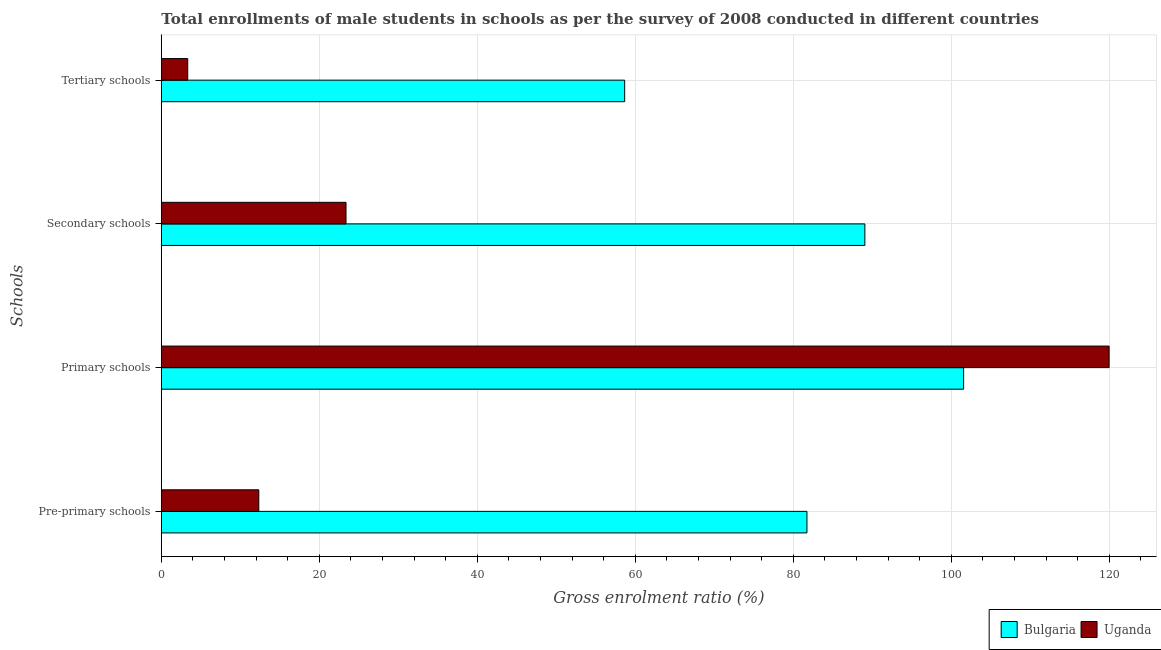How many bars are there on the 4th tick from the top?
Make the answer very short. 2. What is the label of the 2nd group of bars from the top?
Make the answer very short. Secondary schools. What is the gross enrolment ratio(male) in primary schools in Bulgaria?
Give a very brief answer. 101.55. Across all countries, what is the maximum gross enrolment ratio(male) in tertiary schools?
Give a very brief answer. 58.65. Across all countries, what is the minimum gross enrolment ratio(male) in pre-primary schools?
Give a very brief answer. 12.34. In which country was the gross enrolment ratio(male) in secondary schools minimum?
Offer a terse response. Uganda. What is the total gross enrolment ratio(male) in tertiary schools in the graph?
Ensure brevity in your answer.  61.99. What is the difference between the gross enrolment ratio(male) in pre-primary schools in Bulgaria and that in Uganda?
Your answer should be compact. 69.38. What is the difference between the gross enrolment ratio(male) in tertiary schools in Uganda and the gross enrolment ratio(male) in primary schools in Bulgaria?
Offer a terse response. -98.21. What is the average gross enrolment ratio(male) in primary schools per country?
Offer a very short reply. 110.76. What is the difference between the gross enrolment ratio(male) in secondary schools and gross enrolment ratio(male) in primary schools in Uganda?
Make the answer very short. -96.59. In how many countries, is the gross enrolment ratio(male) in pre-primary schools greater than 36 %?
Keep it short and to the point. 1. What is the ratio of the gross enrolment ratio(male) in secondary schools in Bulgaria to that in Uganda?
Give a very brief answer. 3.81. Is the gross enrolment ratio(male) in primary schools in Bulgaria less than that in Uganda?
Offer a very short reply. Yes. Is the difference between the gross enrolment ratio(male) in primary schools in Bulgaria and Uganda greater than the difference between the gross enrolment ratio(male) in secondary schools in Bulgaria and Uganda?
Offer a very short reply. No. What is the difference between the highest and the second highest gross enrolment ratio(male) in tertiary schools?
Make the answer very short. 55.31. What is the difference between the highest and the lowest gross enrolment ratio(male) in pre-primary schools?
Give a very brief answer. 69.38. Is it the case that in every country, the sum of the gross enrolment ratio(male) in tertiary schools and gross enrolment ratio(male) in pre-primary schools is greater than the sum of gross enrolment ratio(male) in secondary schools and gross enrolment ratio(male) in primary schools?
Keep it short and to the point. No. What does the 1st bar from the top in Tertiary schools represents?
Keep it short and to the point. Uganda. What does the 2nd bar from the bottom in Tertiary schools represents?
Your answer should be very brief. Uganda. Is it the case that in every country, the sum of the gross enrolment ratio(male) in pre-primary schools and gross enrolment ratio(male) in primary schools is greater than the gross enrolment ratio(male) in secondary schools?
Provide a short and direct response. Yes. How many bars are there?
Give a very brief answer. 8. How many countries are there in the graph?
Your answer should be compact. 2. Does the graph contain any zero values?
Offer a very short reply. No. What is the title of the graph?
Keep it short and to the point. Total enrollments of male students in schools as per the survey of 2008 conducted in different countries. Does "Sweden" appear as one of the legend labels in the graph?
Your response must be concise. No. What is the label or title of the Y-axis?
Keep it short and to the point. Schools. What is the Gross enrolment ratio (%) of Bulgaria in Pre-primary schools?
Your answer should be compact. 81.72. What is the Gross enrolment ratio (%) of Uganda in Pre-primary schools?
Offer a very short reply. 12.34. What is the Gross enrolment ratio (%) of Bulgaria in Primary schools?
Provide a succinct answer. 101.55. What is the Gross enrolment ratio (%) in Uganda in Primary schools?
Your answer should be compact. 119.97. What is the Gross enrolment ratio (%) in Bulgaria in Secondary schools?
Make the answer very short. 89.05. What is the Gross enrolment ratio (%) in Uganda in Secondary schools?
Provide a short and direct response. 23.38. What is the Gross enrolment ratio (%) of Bulgaria in Tertiary schools?
Offer a very short reply. 58.65. What is the Gross enrolment ratio (%) of Uganda in Tertiary schools?
Ensure brevity in your answer.  3.34. Across all Schools, what is the maximum Gross enrolment ratio (%) in Bulgaria?
Your answer should be compact. 101.55. Across all Schools, what is the maximum Gross enrolment ratio (%) in Uganda?
Make the answer very short. 119.97. Across all Schools, what is the minimum Gross enrolment ratio (%) of Bulgaria?
Keep it short and to the point. 58.65. Across all Schools, what is the minimum Gross enrolment ratio (%) of Uganda?
Your response must be concise. 3.34. What is the total Gross enrolment ratio (%) in Bulgaria in the graph?
Ensure brevity in your answer.  330.98. What is the total Gross enrolment ratio (%) of Uganda in the graph?
Keep it short and to the point. 159.02. What is the difference between the Gross enrolment ratio (%) in Bulgaria in Pre-primary schools and that in Primary schools?
Your answer should be very brief. -19.83. What is the difference between the Gross enrolment ratio (%) in Uganda in Pre-primary schools and that in Primary schools?
Provide a succinct answer. -107.63. What is the difference between the Gross enrolment ratio (%) of Bulgaria in Pre-primary schools and that in Secondary schools?
Keep it short and to the point. -7.33. What is the difference between the Gross enrolment ratio (%) in Uganda in Pre-primary schools and that in Secondary schools?
Keep it short and to the point. -11.04. What is the difference between the Gross enrolment ratio (%) in Bulgaria in Pre-primary schools and that in Tertiary schools?
Your answer should be compact. 23.07. What is the difference between the Gross enrolment ratio (%) of Uganda in Pre-primary schools and that in Tertiary schools?
Ensure brevity in your answer.  9. What is the difference between the Gross enrolment ratio (%) in Bulgaria in Primary schools and that in Secondary schools?
Your answer should be very brief. 12.5. What is the difference between the Gross enrolment ratio (%) of Uganda in Primary schools and that in Secondary schools?
Keep it short and to the point. 96.59. What is the difference between the Gross enrolment ratio (%) of Bulgaria in Primary schools and that in Tertiary schools?
Make the answer very short. 42.9. What is the difference between the Gross enrolment ratio (%) in Uganda in Primary schools and that in Tertiary schools?
Ensure brevity in your answer.  116.63. What is the difference between the Gross enrolment ratio (%) in Bulgaria in Secondary schools and that in Tertiary schools?
Your response must be concise. 30.4. What is the difference between the Gross enrolment ratio (%) in Uganda in Secondary schools and that in Tertiary schools?
Offer a very short reply. 20.04. What is the difference between the Gross enrolment ratio (%) of Bulgaria in Pre-primary schools and the Gross enrolment ratio (%) of Uganda in Primary schools?
Ensure brevity in your answer.  -38.25. What is the difference between the Gross enrolment ratio (%) of Bulgaria in Pre-primary schools and the Gross enrolment ratio (%) of Uganda in Secondary schools?
Provide a short and direct response. 58.34. What is the difference between the Gross enrolment ratio (%) in Bulgaria in Pre-primary schools and the Gross enrolment ratio (%) in Uganda in Tertiary schools?
Keep it short and to the point. 78.38. What is the difference between the Gross enrolment ratio (%) in Bulgaria in Primary schools and the Gross enrolment ratio (%) in Uganda in Secondary schools?
Ensure brevity in your answer.  78.18. What is the difference between the Gross enrolment ratio (%) in Bulgaria in Primary schools and the Gross enrolment ratio (%) in Uganda in Tertiary schools?
Give a very brief answer. 98.21. What is the difference between the Gross enrolment ratio (%) in Bulgaria in Secondary schools and the Gross enrolment ratio (%) in Uganda in Tertiary schools?
Ensure brevity in your answer.  85.71. What is the average Gross enrolment ratio (%) of Bulgaria per Schools?
Keep it short and to the point. 82.74. What is the average Gross enrolment ratio (%) in Uganda per Schools?
Offer a terse response. 39.76. What is the difference between the Gross enrolment ratio (%) of Bulgaria and Gross enrolment ratio (%) of Uganda in Pre-primary schools?
Ensure brevity in your answer.  69.38. What is the difference between the Gross enrolment ratio (%) of Bulgaria and Gross enrolment ratio (%) of Uganda in Primary schools?
Your answer should be very brief. -18.41. What is the difference between the Gross enrolment ratio (%) in Bulgaria and Gross enrolment ratio (%) in Uganda in Secondary schools?
Provide a succinct answer. 65.67. What is the difference between the Gross enrolment ratio (%) in Bulgaria and Gross enrolment ratio (%) in Uganda in Tertiary schools?
Your answer should be compact. 55.31. What is the ratio of the Gross enrolment ratio (%) of Bulgaria in Pre-primary schools to that in Primary schools?
Offer a terse response. 0.8. What is the ratio of the Gross enrolment ratio (%) of Uganda in Pre-primary schools to that in Primary schools?
Offer a terse response. 0.1. What is the ratio of the Gross enrolment ratio (%) in Bulgaria in Pre-primary schools to that in Secondary schools?
Your response must be concise. 0.92. What is the ratio of the Gross enrolment ratio (%) in Uganda in Pre-primary schools to that in Secondary schools?
Provide a succinct answer. 0.53. What is the ratio of the Gross enrolment ratio (%) of Bulgaria in Pre-primary schools to that in Tertiary schools?
Keep it short and to the point. 1.39. What is the ratio of the Gross enrolment ratio (%) in Uganda in Pre-primary schools to that in Tertiary schools?
Keep it short and to the point. 3.69. What is the ratio of the Gross enrolment ratio (%) of Bulgaria in Primary schools to that in Secondary schools?
Your answer should be compact. 1.14. What is the ratio of the Gross enrolment ratio (%) of Uganda in Primary schools to that in Secondary schools?
Keep it short and to the point. 5.13. What is the ratio of the Gross enrolment ratio (%) of Bulgaria in Primary schools to that in Tertiary schools?
Your answer should be compact. 1.73. What is the ratio of the Gross enrolment ratio (%) of Uganda in Primary schools to that in Tertiary schools?
Keep it short and to the point. 35.91. What is the ratio of the Gross enrolment ratio (%) in Bulgaria in Secondary schools to that in Tertiary schools?
Your answer should be compact. 1.52. What is the ratio of the Gross enrolment ratio (%) of Uganda in Secondary schools to that in Tertiary schools?
Give a very brief answer. 7. What is the difference between the highest and the second highest Gross enrolment ratio (%) in Bulgaria?
Ensure brevity in your answer.  12.5. What is the difference between the highest and the second highest Gross enrolment ratio (%) of Uganda?
Offer a very short reply. 96.59. What is the difference between the highest and the lowest Gross enrolment ratio (%) of Bulgaria?
Ensure brevity in your answer.  42.9. What is the difference between the highest and the lowest Gross enrolment ratio (%) of Uganda?
Offer a very short reply. 116.63. 